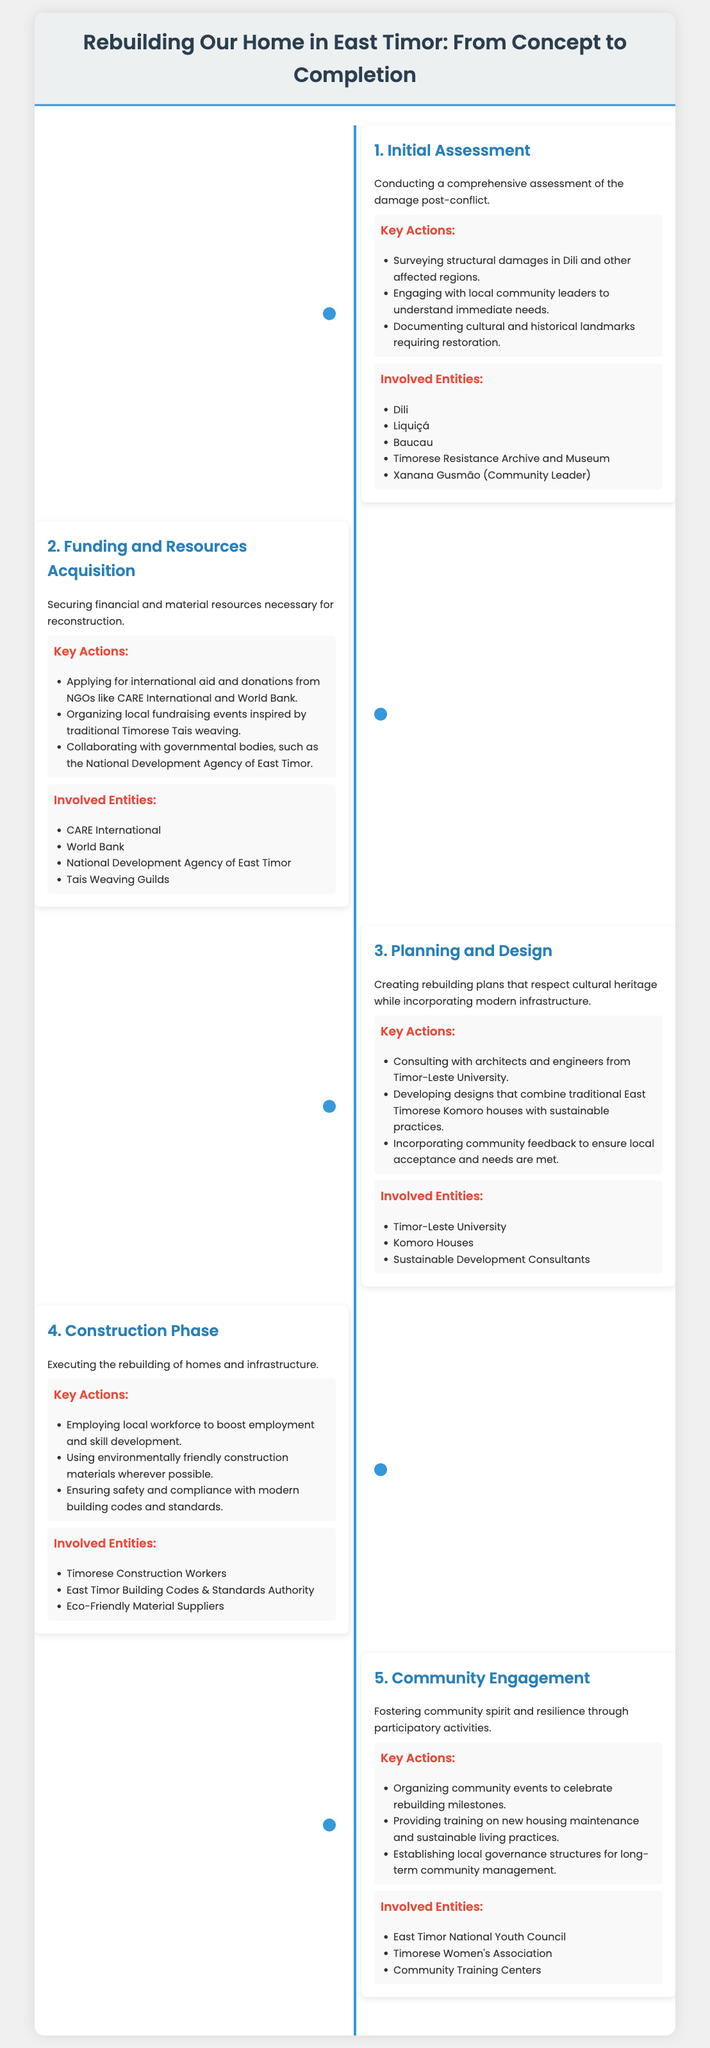What is the first step in the rebuilding process? The first step is conducting a comprehensive assessment of the damage post-conflict.
Answer: Initial Assessment Who is a community leader mentioned in the document? Xanana Gusmão is identified as a community leader involved in the assessment phase.
Answer: Xanana Gusmão How many key actions are outlined in the construction phase? The construction phase includes three key actions detailed in the document.
Answer: 3 Which organization is involved in securing funds for the project? CARE International is listed as one of the entities involved in securing funds and resources.
Answer: CARE International What is the goal of the community engagement phase? The goal is to foster community spirit and resilience through participatory activities.
Answer: Community spirit and resilience What type of construction materials are preferred during the construction phase? The preference is for environmentally friendly construction materials.
Answer: Environmentally friendly materials Which university is involved in the planning and design stage? Timor-Leste University is the institution mentioned as part of the planning and design phase.
Answer: Timor-Leste University What is the main theme of the document? The main theme revolves around the process of rebuilding homes in East Timor after conflict.
Answer: Rebuilding Homes in East Timor 